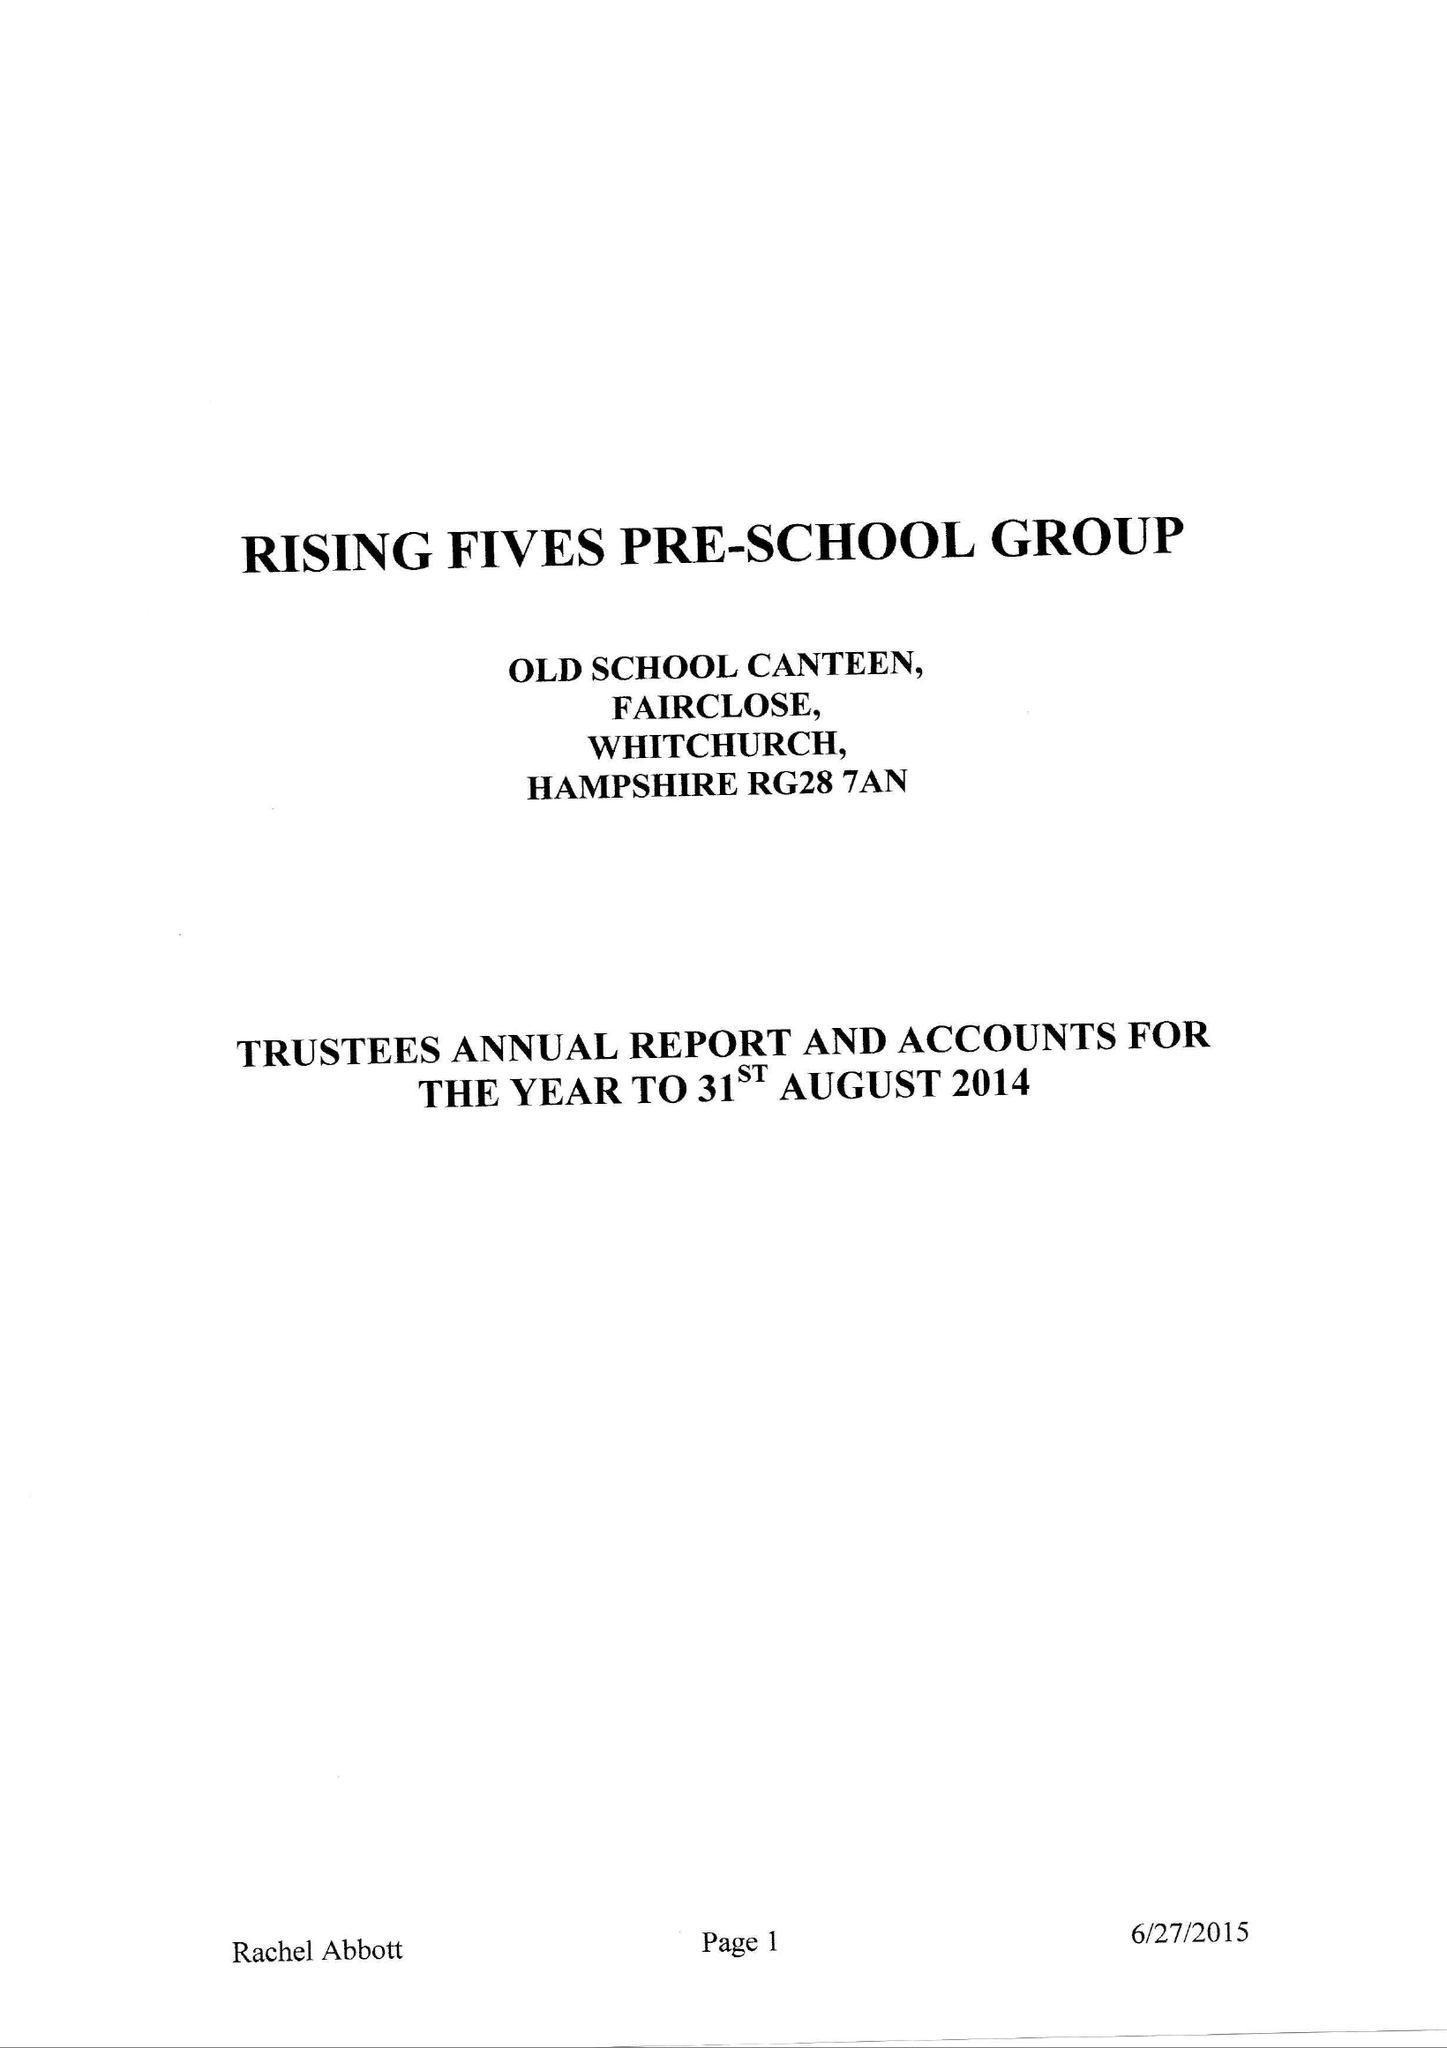What is the value for the charity_name?
Answer the question using a single word or phrase. Rising Fives Pre-School Group 